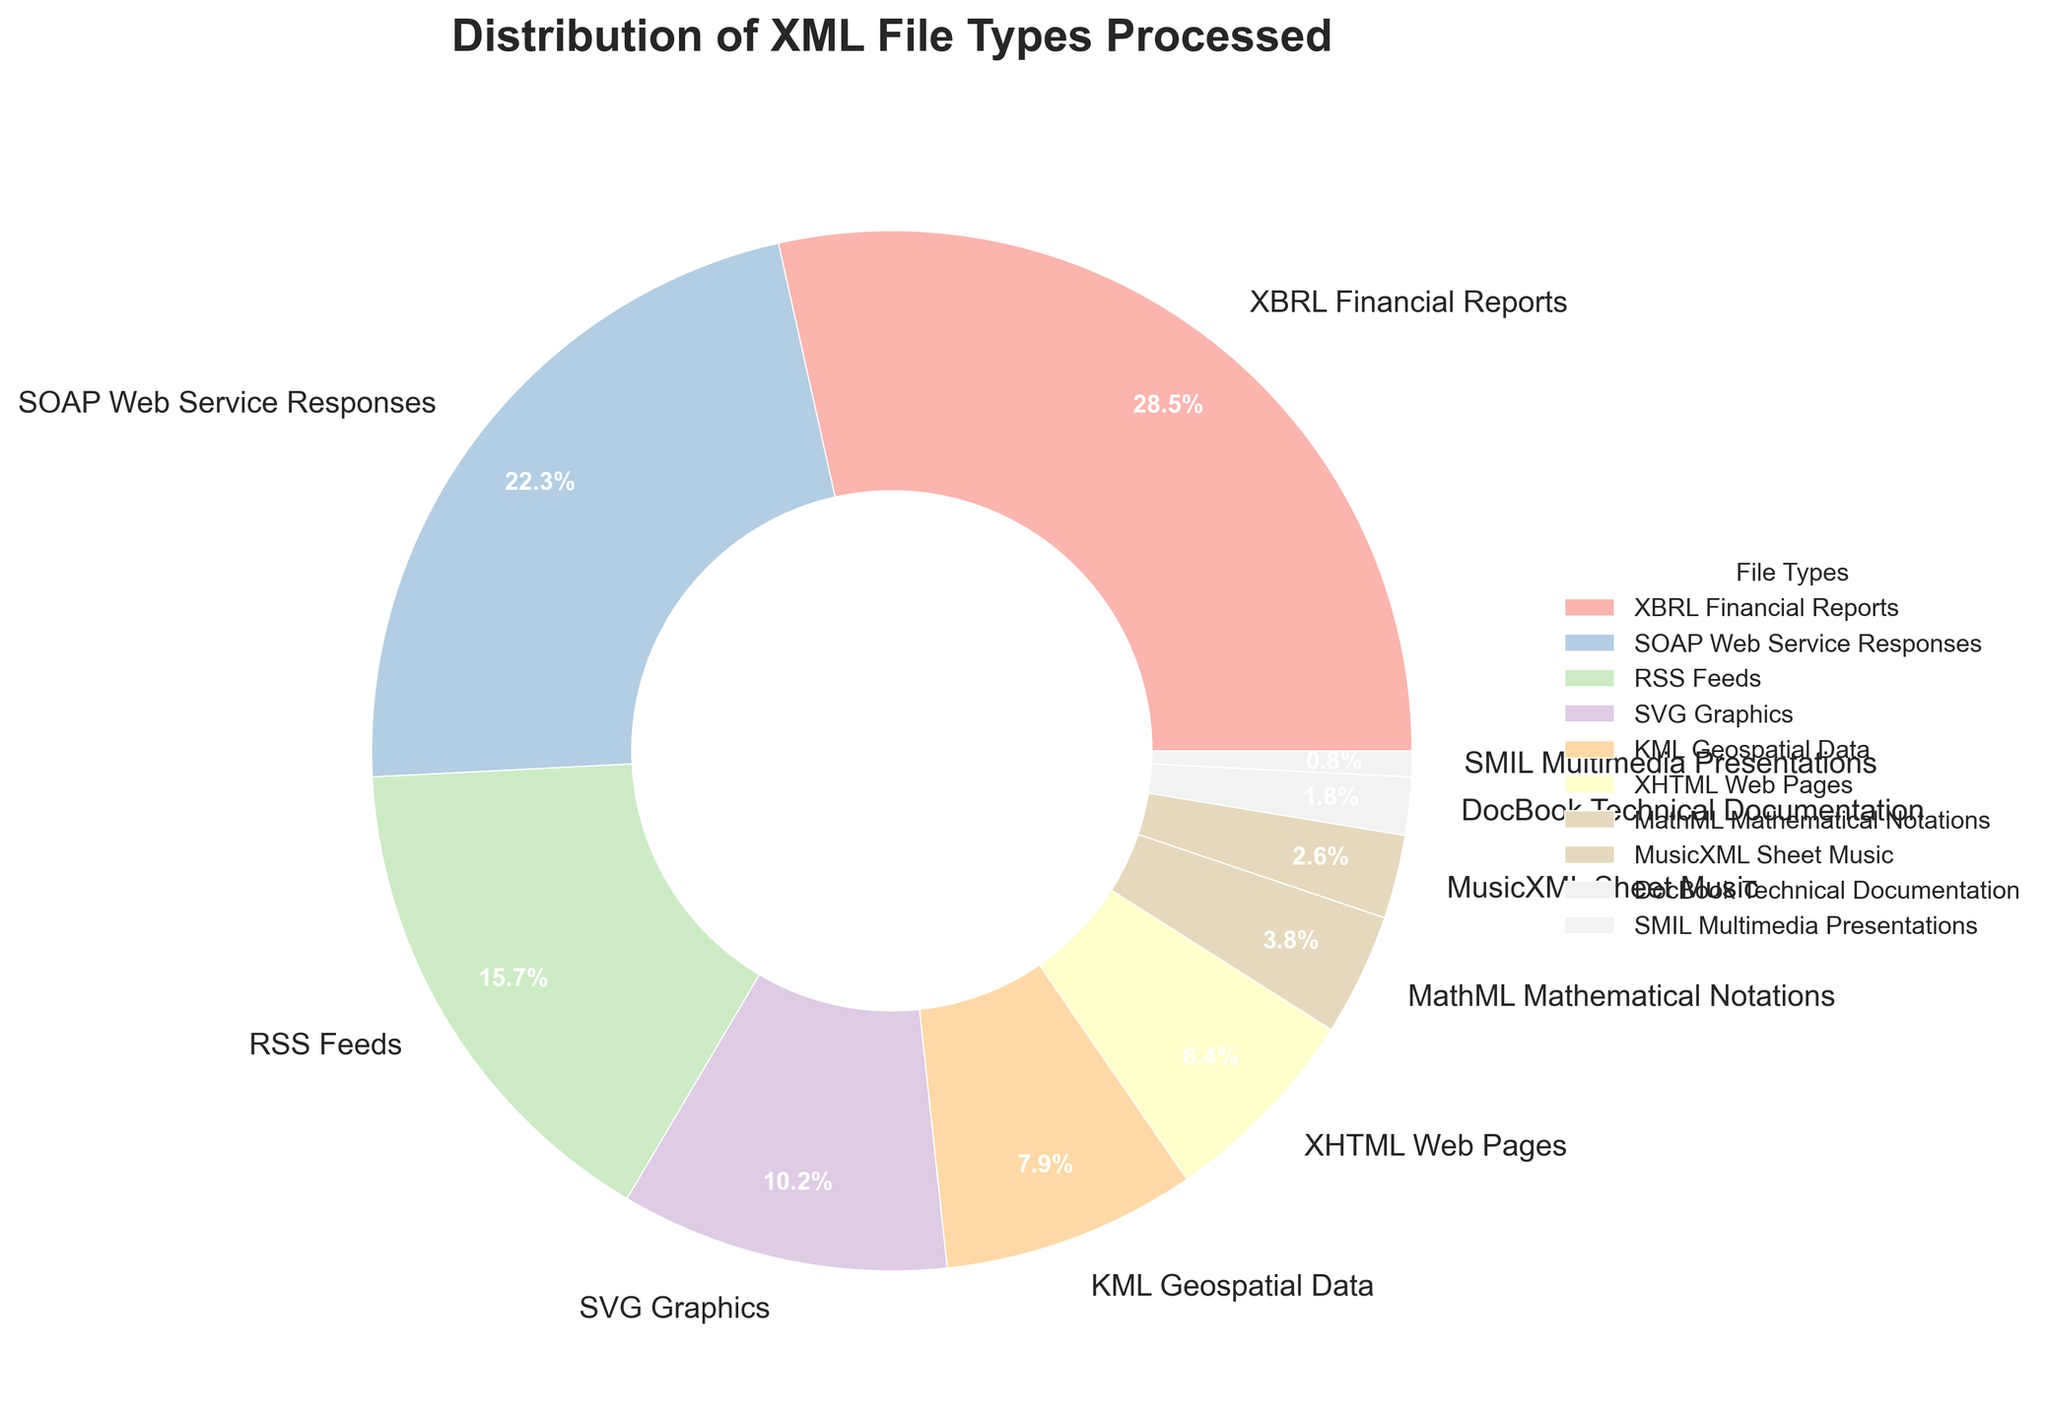What's the most common type of XML file processed by the system? The pie chart shows that "XBRL Financial Reports" has the highest percentage among the listed file types, taking up 28.5% of the total.
Answer: XBRL Financial Reports Which file type is processed more: "XHTML Web Pages" or "MathML Mathematical Notations"? The chart shows that "XHTML Web Pages" has a percentage of 6.4% while "MathML Mathematical Notations" has 3.8%. Therefore, "XHTML Web Pages" is processed more.
Answer: XHTML Web Pages Calculate the total percentage of "SVG Graphics", "KML Geospatial Data", and "MathML Mathematical Notations" combined. The percentages are 10.2% for "SVG Graphics", 7.9% for "KML Geospatial Data", and 3.8% for "MathML Mathematical Notations". Adding these values together gives 10.2 + 7.9 + 3.8 = 21.9%.
Answer: 21.9% Which file type has the smallest share in the system's processing? The file type "SMIL Multimedia Presentations" has the smallest share at 0.8%.
Answer: SMIL Multimedia Presentations Compare the combined percentage of "RSS Feeds" and "SOAP Web Service Responses" to "XBRL Financial Reports". Which is greater? The combined percentage of "RSS Feeds" (15.7%) and "SOAP Web Service Responses" (22.3%) is 15.7 + 22.3 = 38%, which is greater than the 28.5% for "XBRL Financial Reports".
Answer: RSS Feeds and SOAP Web Service Responses How much more prevalent is "XBRL Financial Reports" compared to "SOAP Web Service Responses"? "XBRL Financial Reports" has a share of 28.5% while "SOAP Web Service Responses" have 22.3%. The difference is 28.5 - 22.3 = 6.2%.
Answer: 6.2% Identify the file type represented by the second smallest percentage and state its share. The second smallest percentage is 1.8%, which corresponds to "DocBook Technical Documentation".
Answer: DocBook Technical Documentation What is the percentage difference between "MathML Mathematical Notations" and "MusicXML Sheet Music"? "MathML Mathematical Notations" has a percentage of 3.8%, and "MusicXML Sheet Music" has 2.6%. The difference is 3.8 - 2.6 = 1.2%.
Answer: 1.2% List the file types that comprise more than 10% each of the processed files. The file types that each comprise more than 10% are "XBRL Financial Reports" (28.5%) and "SOAP Web Service Responses" (22.3%), and "RSS Feeds" (15.7%), and "SVG Graphics" (10.2%).
Answer: XBRL Financial Reports, SOAP Web Service Responses, RSS Feeds, SVG Graphics 